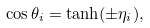<formula> <loc_0><loc_0><loc_500><loc_500>\cos { \theta _ { i } } = \tanh ( { \pm \eta _ { i } } ) ,</formula> 